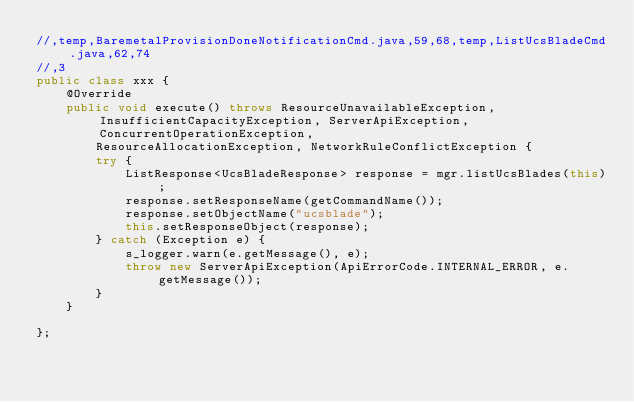<code> <loc_0><loc_0><loc_500><loc_500><_Java_>//,temp,BaremetalProvisionDoneNotificationCmd.java,59,68,temp,ListUcsBladeCmd.java,62,74
//,3
public class xxx {
    @Override
    public void execute() throws ResourceUnavailableException, InsufficientCapacityException, ServerApiException, ConcurrentOperationException,
        ResourceAllocationException, NetworkRuleConflictException {
        try {
            ListResponse<UcsBladeResponse> response = mgr.listUcsBlades(this);
            response.setResponseName(getCommandName());
            response.setObjectName("ucsblade");
            this.setResponseObject(response);
        } catch (Exception e) {
            s_logger.warn(e.getMessage(), e);
            throw new ServerApiException(ApiErrorCode.INTERNAL_ERROR, e.getMessage());
        }
    }

};</code> 